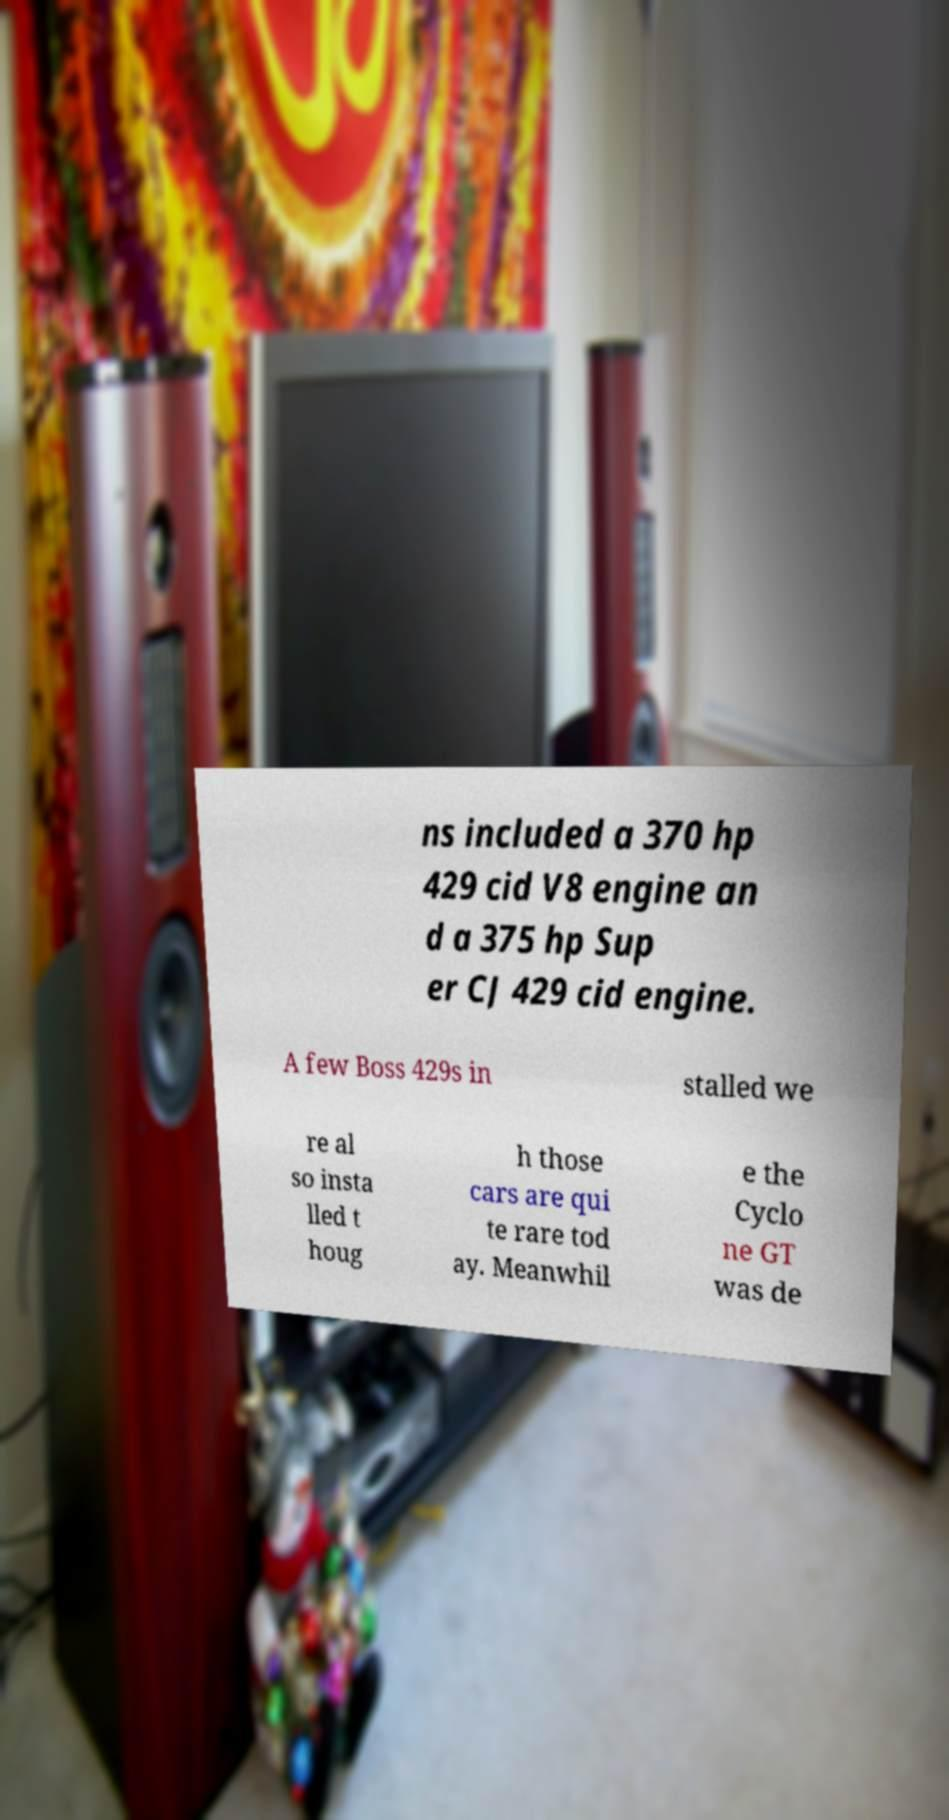Could you assist in decoding the text presented in this image and type it out clearly? ns included a 370 hp 429 cid V8 engine an d a 375 hp Sup er CJ 429 cid engine. A few Boss 429s in stalled we re al so insta lled t houg h those cars are qui te rare tod ay. Meanwhil e the Cyclo ne GT was de 